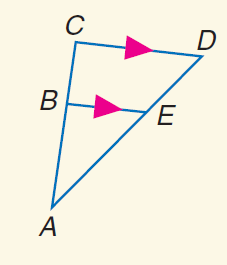Answer the mathemtical geometry problem and directly provide the correct option letter.
Question: Find C D if A E = 8, E D = 4, and B E = 6.
Choices: A: 4 B: 6 C: 8 D: 9 D 